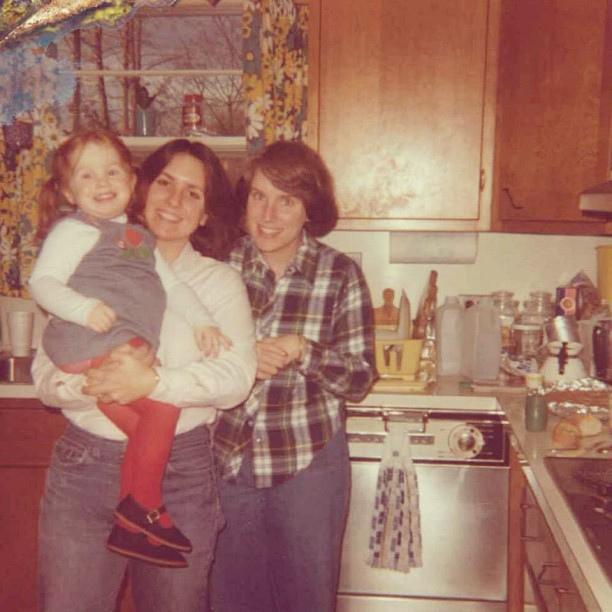Was this picture taken today?
Quick response, please. No. Are they drinking wine?
Give a very brief answer. No. Where are the curtains?
Answer briefly. Window. Who is being held?
Short answer required. Girl. 